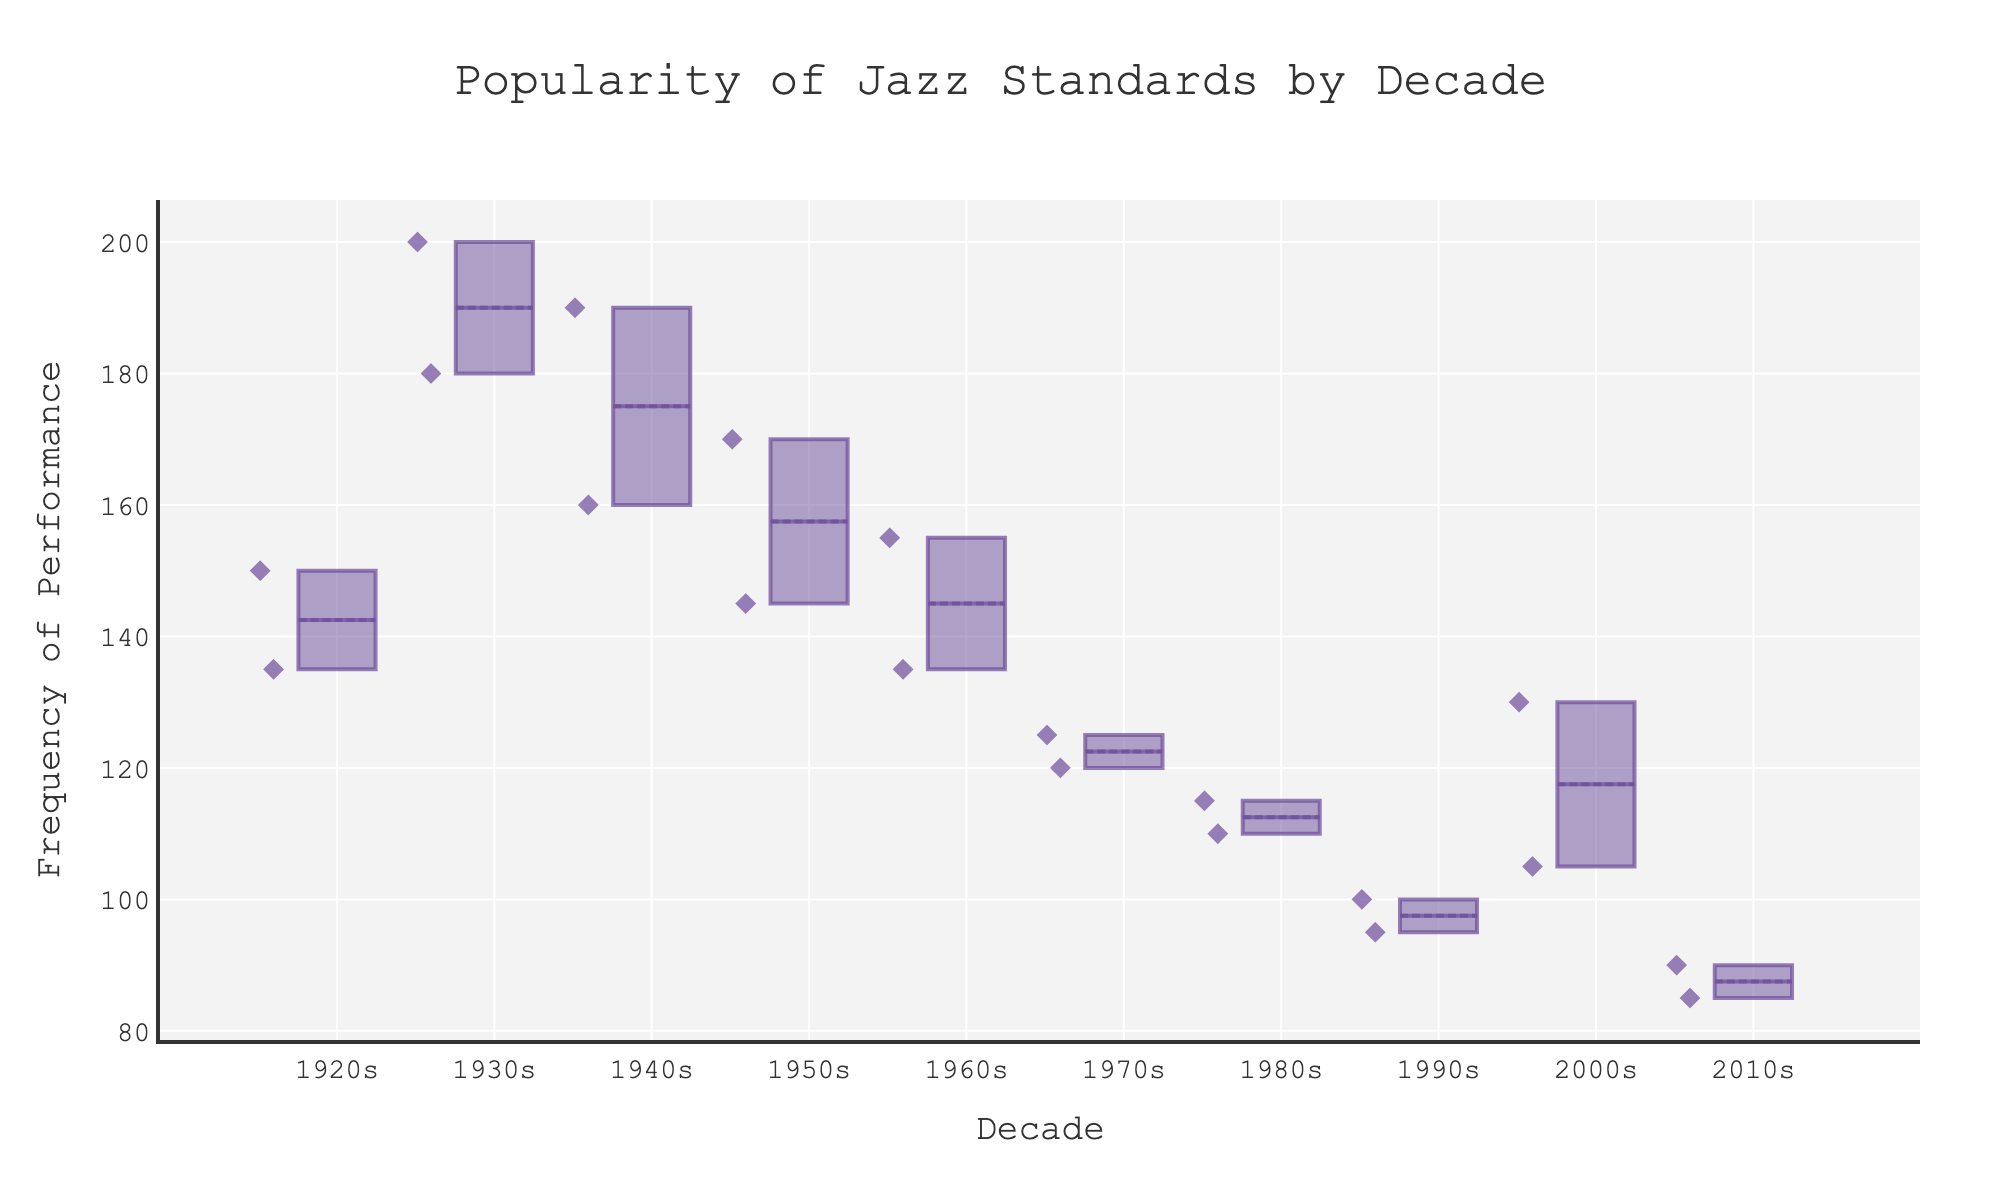What's the title of the figure? The title of the figure is usually positioned at the top and is meant to provide a succinct description of the visualization.
Answer: Popularity of Jazz Standards by Decade Which decade shows the highest median frequency of performance? To answer this, look for the box plot with the highest line inside the box (the median).
Answer: 1940s Which decade has the widest variability in frequency of performance? Examine the range between the top and bottom whiskers of each box plot. The decade with the longest whiskers shows the greatest variability.
Answer: 1940s What's the range of frequency of performance for the 1950s? Identify the top and bottom whiskers for the 1950s box plot and calculate the range by subtracting the minimum value from the maximum value.
Answer: 170 - 145 = 25 How does the median frequency of the 1990s compare to that of the 2000s? Compare the median lines inside the boxes for the 1990s and 2000s box plots.
Answer: The 1990s median is lower than the 2000s median What's the interquartile range (IQR) for the 1960s? The IQR is the range between the top and bottom edges of the box (Q3 - Q1). Find these values for the 1960s box plot and calculate the difference.
Answer: 155 - 135 = 20 Which decade has the most consistent frequency of performance? Look for the box plot with the shortest interquartile range and smallest whiskers, indicating less variability and higher consistency.
Answer: 1970s Are there outliers in the 1930s' frequency of performance? Outliers in a box plot are usually represented by points beyond the whiskers. Check the 1930s box for such points.
Answer: No How does the mean frequency of performance in the 2010s compare to the median? Locate the mean (often indicated by a dot or a line) and compare it to the median line inside the box for the 2010s.
Answer: The mean is slightly lower than the median What can you infer about the popularity trend of jazz standards over the decades? By examining the median lines and overall variability in each decade's box plot, you can observe how the popularity's consistency and frequency have evolved.
Answer: Trend suggests decreasing frequency and increased variability over time 